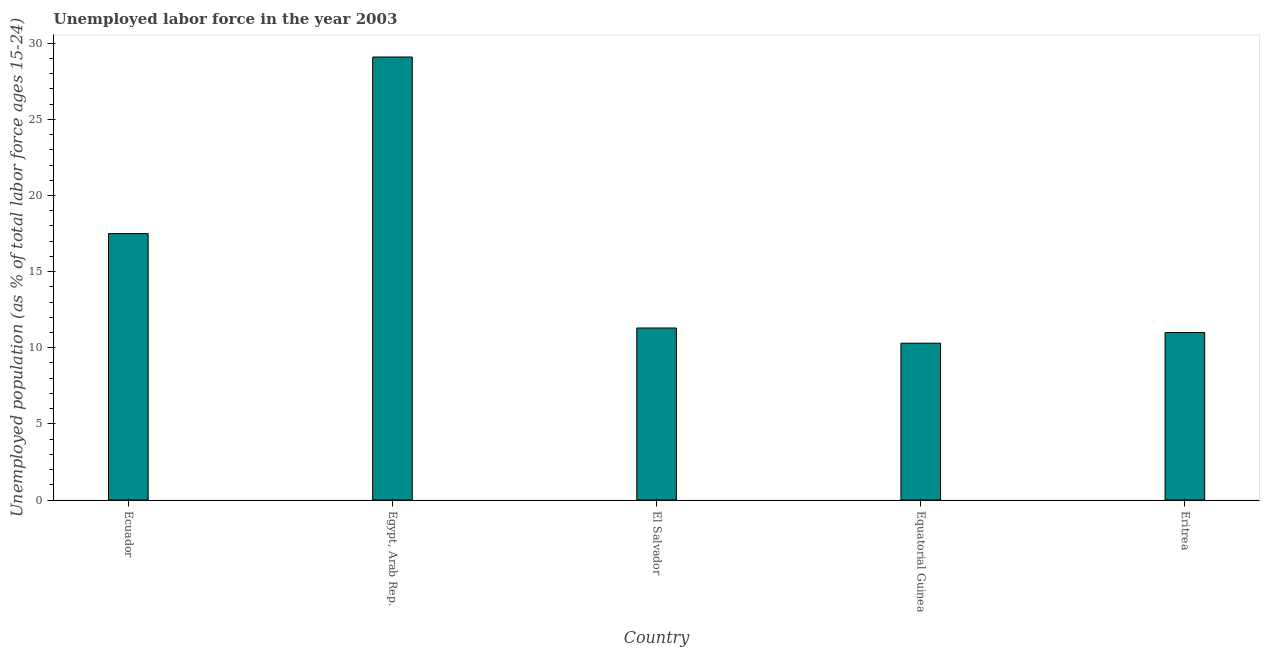Does the graph contain grids?
Provide a short and direct response. No. What is the title of the graph?
Make the answer very short. Unemployed labor force in the year 2003. What is the label or title of the Y-axis?
Give a very brief answer. Unemployed population (as % of total labor force ages 15-24). What is the total unemployed youth population in El Salvador?
Provide a short and direct response. 11.3. Across all countries, what is the maximum total unemployed youth population?
Your answer should be very brief. 29.1. Across all countries, what is the minimum total unemployed youth population?
Your answer should be compact. 10.3. In which country was the total unemployed youth population maximum?
Give a very brief answer. Egypt, Arab Rep. In which country was the total unemployed youth population minimum?
Ensure brevity in your answer.  Equatorial Guinea. What is the sum of the total unemployed youth population?
Ensure brevity in your answer.  79.2. What is the average total unemployed youth population per country?
Keep it short and to the point. 15.84. What is the median total unemployed youth population?
Your answer should be very brief. 11.3. What is the ratio of the total unemployed youth population in Ecuador to that in Eritrea?
Provide a succinct answer. 1.59. Is the total unemployed youth population in El Salvador less than that in Equatorial Guinea?
Offer a terse response. No. What is the difference between the highest and the second highest total unemployed youth population?
Give a very brief answer. 11.6. What is the difference between the highest and the lowest total unemployed youth population?
Give a very brief answer. 18.8. Are the values on the major ticks of Y-axis written in scientific E-notation?
Provide a succinct answer. No. What is the Unemployed population (as % of total labor force ages 15-24) in Ecuador?
Make the answer very short. 17.5. What is the Unemployed population (as % of total labor force ages 15-24) of Egypt, Arab Rep.?
Give a very brief answer. 29.1. What is the Unemployed population (as % of total labor force ages 15-24) in El Salvador?
Keep it short and to the point. 11.3. What is the Unemployed population (as % of total labor force ages 15-24) in Equatorial Guinea?
Offer a very short reply. 10.3. What is the difference between the Unemployed population (as % of total labor force ages 15-24) in Ecuador and Egypt, Arab Rep.?
Give a very brief answer. -11.6. What is the difference between the Unemployed population (as % of total labor force ages 15-24) in Ecuador and Eritrea?
Provide a short and direct response. 6.5. What is the difference between the Unemployed population (as % of total labor force ages 15-24) in Egypt, Arab Rep. and El Salvador?
Give a very brief answer. 17.8. What is the difference between the Unemployed population (as % of total labor force ages 15-24) in Egypt, Arab Rep. and Eritrea?
Your response must be concise. 18.1. What is the difference between the Unemployed population (as % of total labor force ages 15-24) in El Salvador and Equatorial Guinea?
Keep it short and to the point. 1. What is the ratio of the Unemployed population (as % of total labor force ages 15-24) in Ecuador to that in Egypt, Arab Rep.?
Your answer should be compact. 0.6. What is the ratio of the Unemployed population (as % of total labor force ages 15-24) in Ecuador to that in El Salvador?
Provide a succinct answer. 1.55. What is the ratio of the Unemployed population (as % of total labor force ages 15-24) in Ecuador to that in Equatorial Guinea?
Provide a succinct answer. 1.7. What is the ratio of the Unemployed population (as % of total labor force ages 15-24) in Ecuador to that in Eritrea?
Offer a very short reply. 1.59. What is the ratio of the Unemployed population (as % of total labor force ages 15-24) in Egypt, Arab Rep. to that in El Salvador?
Provide a succinct answer. 2.58. What is the ratio of the Unemployed population (as % of total labor force ages 15-24) in Egypt, Arab Rep. to that in Equatorial Guinea?
Your answer should be compact. 2.83. What is the ratio of the Unemployed population (as % of total labor force ages 15-24) in Egypt, Arab Rep. to that in Eritrea?
Your response must be concise. 2.65. What is the ratio of the Unemployed population (as % of total labor force ages 15-24) in El Salvador to that in Equatorial Guinea?
Keep it short and to the point. 1.1. What is the ratio of the Unemployed population (as % of total labor force ages 15-24) in El Salvador to that in Eritrea?
Give a very brief answer. 1.03. What is the ratio of the Unemployed population (as % of total labor force ages 15-24) in Equatorial Guinea to that in Eritrea?
Offer a terse response. 0.94. 